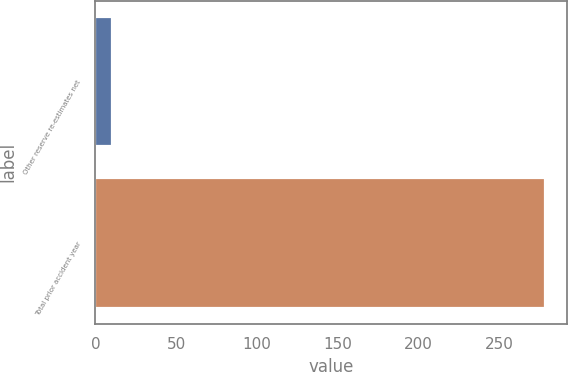<chart> <loc_0><loc_0><loc_500><loc_500><bar_chart><fcel>Other reserve re-estimates net<fcel>Total prior accident year<nl><fcel>10<fcel>278<nl></chart> 